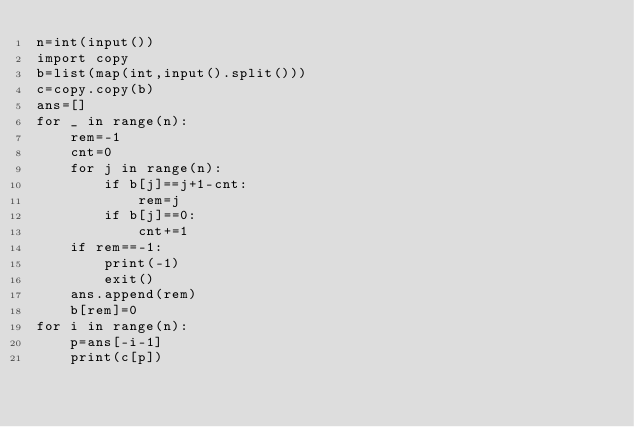<code> <loc_0><loc_0><loc_500><loc_500><_Python_>n=int(input())
import copy
b=list(map(int,input().split()))
c=copy.copy(b)
ans=[]
for _ in range(n):
	rem=-1
	cnt=0
	for j in range(n):
		if b[j]==j+1-cnt:
			rem=j
		if b[j]==0:
			cnt+=1
	if rem==-1:
		print(-1)
		exit()
	ans.append(rem)
	b[rem]=0
for i in range(n):
	p=ans[-i-1]
	print(c[p])</code> 